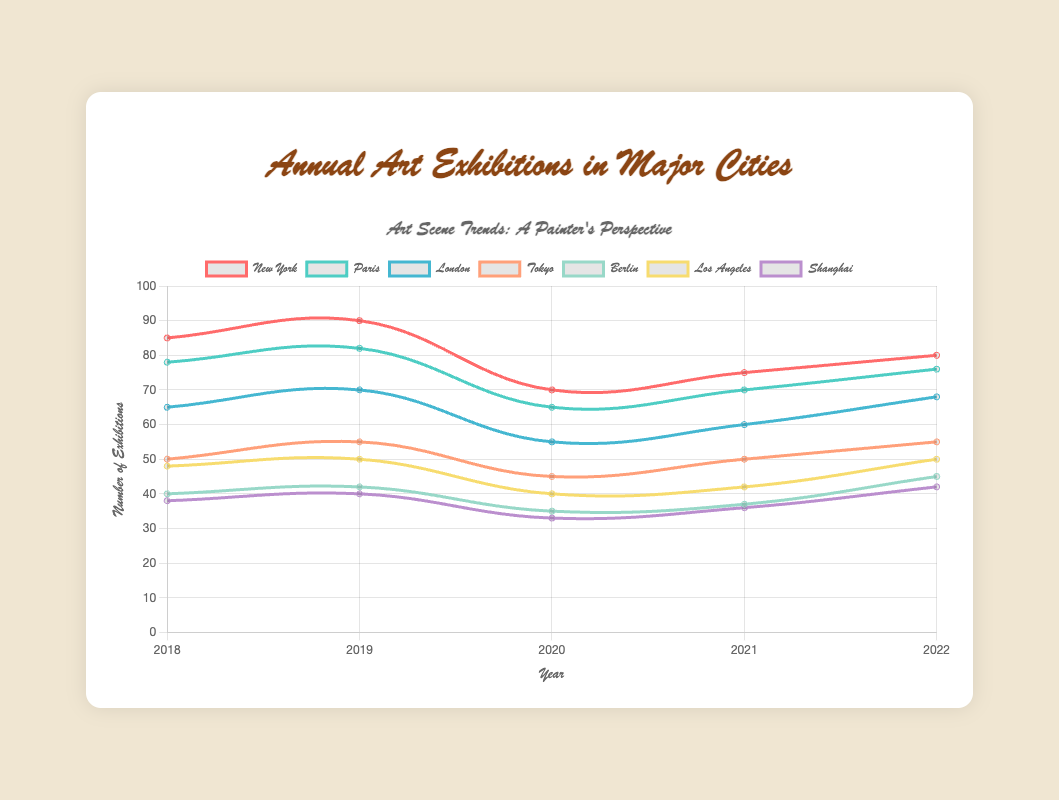Which city had the highest number of art exhibitions in 2019? By examining the line chart, the highest y-value for 2019 corresponds to New York with 90 exhibitions.
Answer: New York Which city experienced the largest decrease in the number of art exhibitions from 2019 to 2020? Subtracting the values for 2020 from 2019 for each city, New York went from 90 to 70 (decrease of 20), Paris from 82 to 65 (decrease of 17), London from 70 to 55 (decrease of 15), Tokyo from 55 to 45 (decrease of 10), Berlin from 42 to 35 (decrease of 7), Los Angeles from 50 to 40 (decrease of 10), and Shanghai from 40 to 33 (decrease of 7). The largest decrease is for New York.
Answer: New York In which year did Berlin hold the minimum number of art exhibitions? Observing Berlin's values on the chart, the minimum value of 35 occurred in 2020.
Answer: 2020 Which city had a consistent increase in art exhibitions numbers from 2020 to 2022? Checking the values from 2020 to 2022 for each city, (New York: 70, 75, 80), (Paris: 65, 70, 76), (London: 55, 60, 68), (Tokyo: 45, 50, 55), (Berlin: 35, 37, 45), (Los Angeles: 40, 42, 50), (Shanghai: 33, 36, 42). All listed cities show a consistent increase.
Answer: New York, Paris, London, Tokyo, Berlin, Los Angeles, Shanghai In 2022, which city had the second-lowest number of art exhibitions? By looking at the 2022 data, the order from lowest to highest is Berlin (45), Shanghai (42), Tokyo (55), Los Angeles (50), London (68), Paris (76), New York (80). Shanghai had the second-lowest.
Answer: Shanghai What is the average number of art exhibitions held in Tokyo from 2018 to 2022? Summing up Tokyo's values over the years (50 + 55 + 45 + 50 + 55) equals 255. Dividing by the number of years (5) gives an average of 51.
Answer: 51 Compare the number of art exhibitions held in New York and Paris in 2020. Which city held more exhibitions and by how many? In 2020, New York held 70 exhibitions and Paris held 65 exhibitions. New York held 5 more exhibitions than Paris.
Answer: New York, 5 What was the total number of art exhibitions held in Berlin and Los Angeles combined in 2022? Summing up the numbers for Berlin (45) and Los Angeles (50) in 2022, the total is 45 + 50 = 95.
Answer: 95 